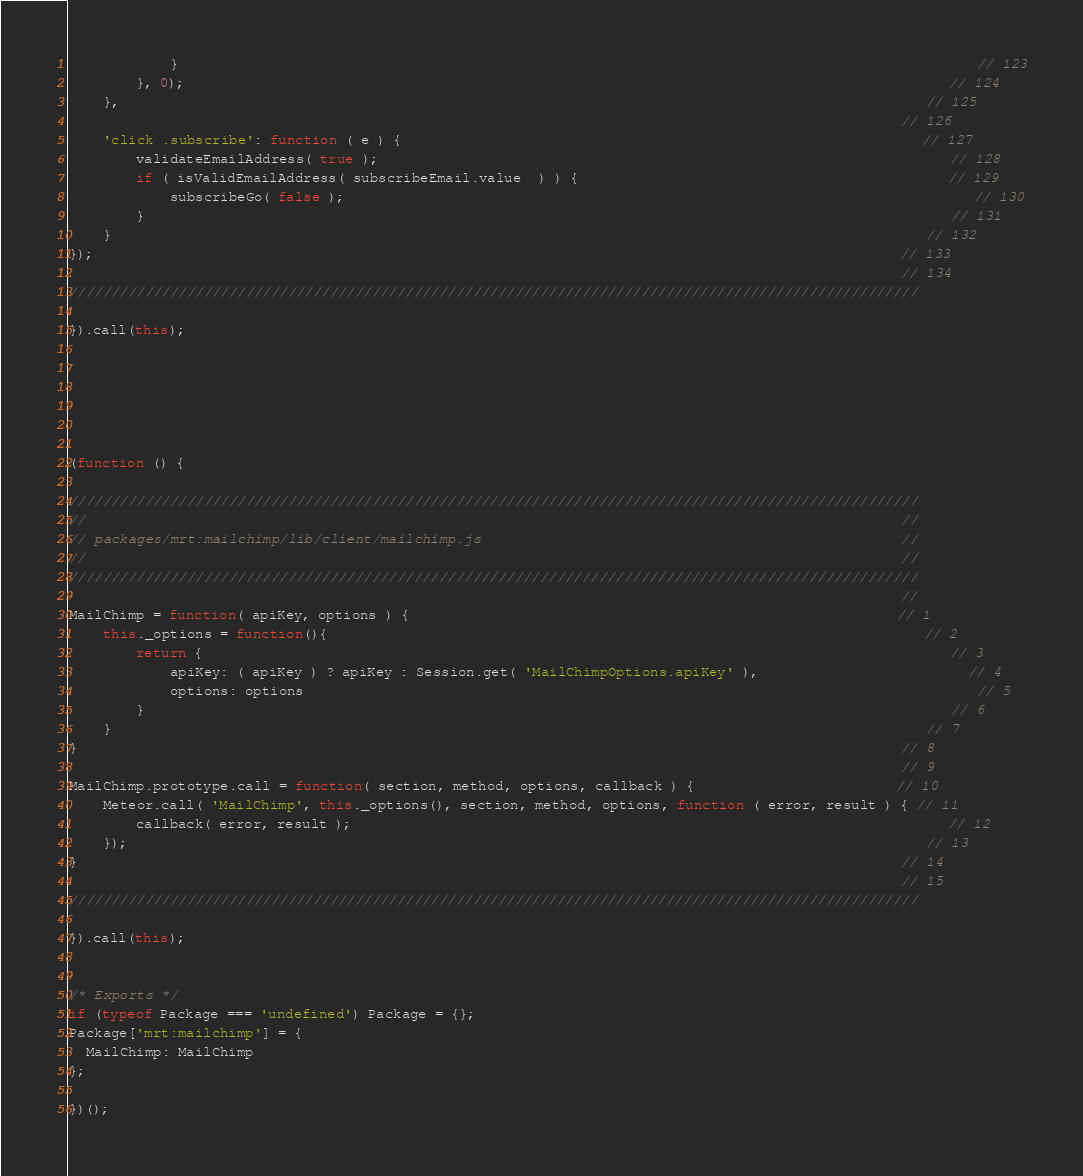Convert code to text. <code><loc_0><loc_0><loc_500><loc_500><_JavaScript_>			}                                                                                               // 123
		}, 0);                                                                                           // 124
	},                                                                                                // 125
                                                                                                   // 126
	'click .subscribe': function ( e ) {                                                              // 127
		validateEmailAddress( true );                                                                    // 128
		if ( isValidEmailAddress( subscribeEmail.value  ) ) {                                            // 129
			subscribeGo( false );                                                                           // 130
		}                                                                                                // 131
	}                                                                                                 // 132
});                                                                                                // 133
                                                                                                   // 134
/////////////////////////////////////////////////////////////////////////////////////////////////////

}).call(this);






(function () {

/////////////////////////////////////////////////////////////////////////////////////////////////////
//                                                                                                 //
// packages/mrt:mailchimp/lib/client/mailchimp.js                                                  //
//                                                                                                 //
/////////////////////////////////////////////////////////////////////////////////////////////////////
                                                                                                   //
MailChimp = function( apiKey, options ) {                                                          // 1
	this._options = function(){                                                                       // 2
		return {                                                                                         // 3
			apiKey: ( apiKey ) ? apiKey : Session.get( 'MailChimpOptions.apiKey' ),                         // 4
			options: options                                                                                // 5
		}                                                                                                // 6
	}                                                                                                 // 7
}                                                                                                  // 8
                                                                                                   // 9
MailChimp.prototype.call = function( section, method, options, callback ) {                        // 10
	Meteor.call( 'MailChimp', this._options(), section, method, options, function ( error, result ) { // 11
		callback( error, result );                                                                       // 12
	});                                                                                               // 13
}                                                                                                  // 14
                                                                                                   // 15
/////////////////////////////////////////////////////////////////////////////////////////////////////

}).call(this);


/* Exports */
if (typeof Package === 'undefined') Package = {};
Package['mrt:mailchimp'] = {
  MailChimp: MailChimp
};

})();
</code> 